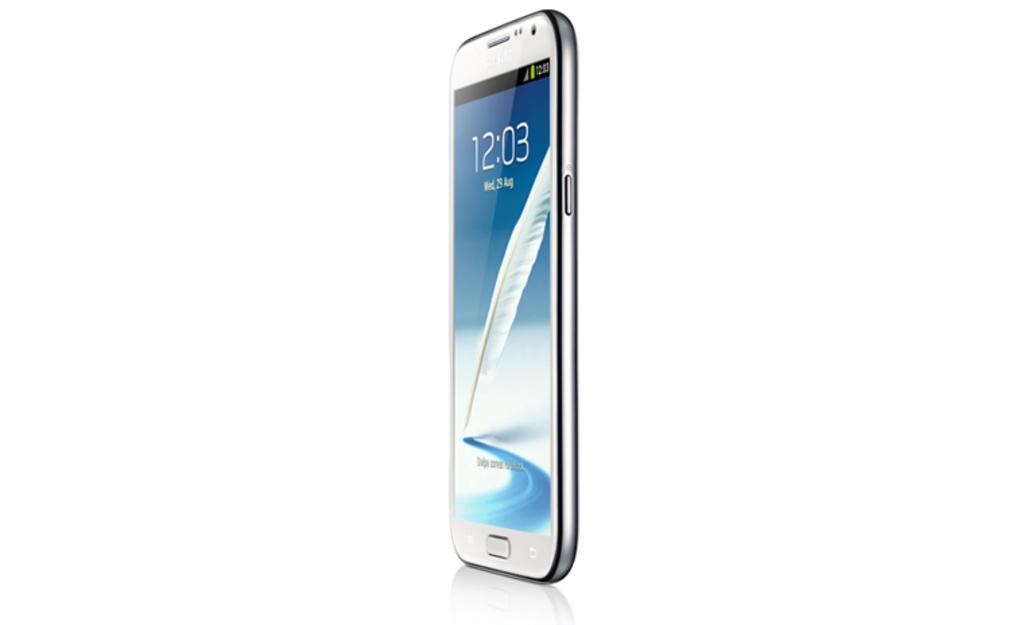What time is on the screen?
Offer a terse response. 12:03. What day of the week is shown on the phone?
Offer a terse response. Wednesday. 